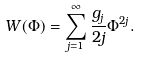<formula> <loc_0><loc_0><loc_500><loc_500>W ( \Phi ) = \sum _ { j = 1 } ^ { \infty } \frac { g _ { j } } { 2 j } \Phi ^ { 2 j } .</formula> 